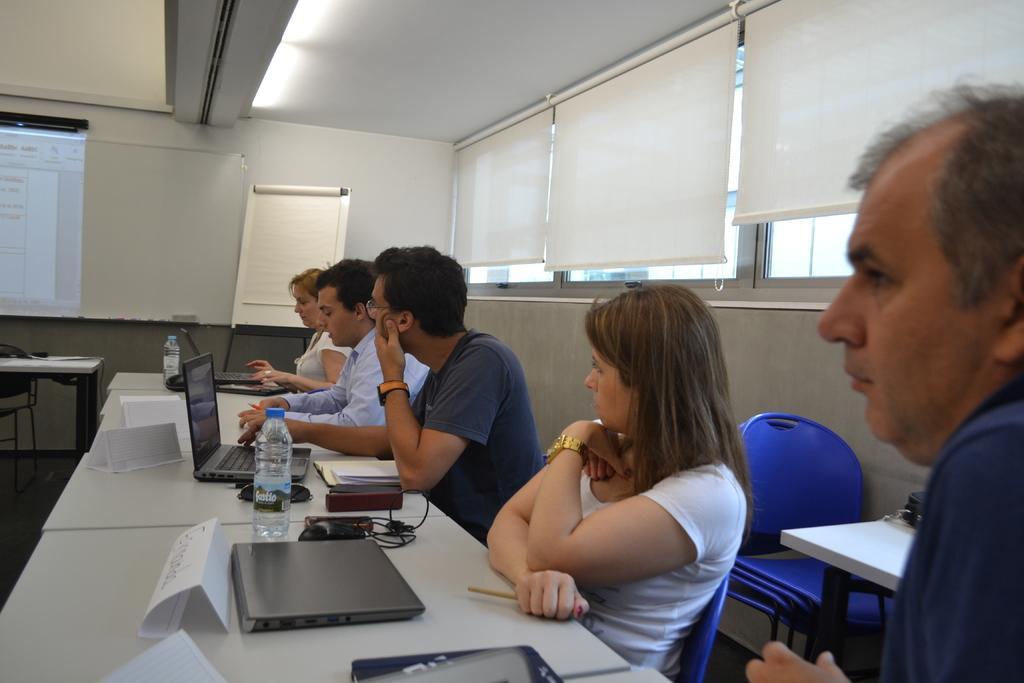Please provide a concise description of this image. In this image there are group of people sitting in chair near the table and in table there are name paper, laptop, bottle, book and in background there is screen , table , board. 